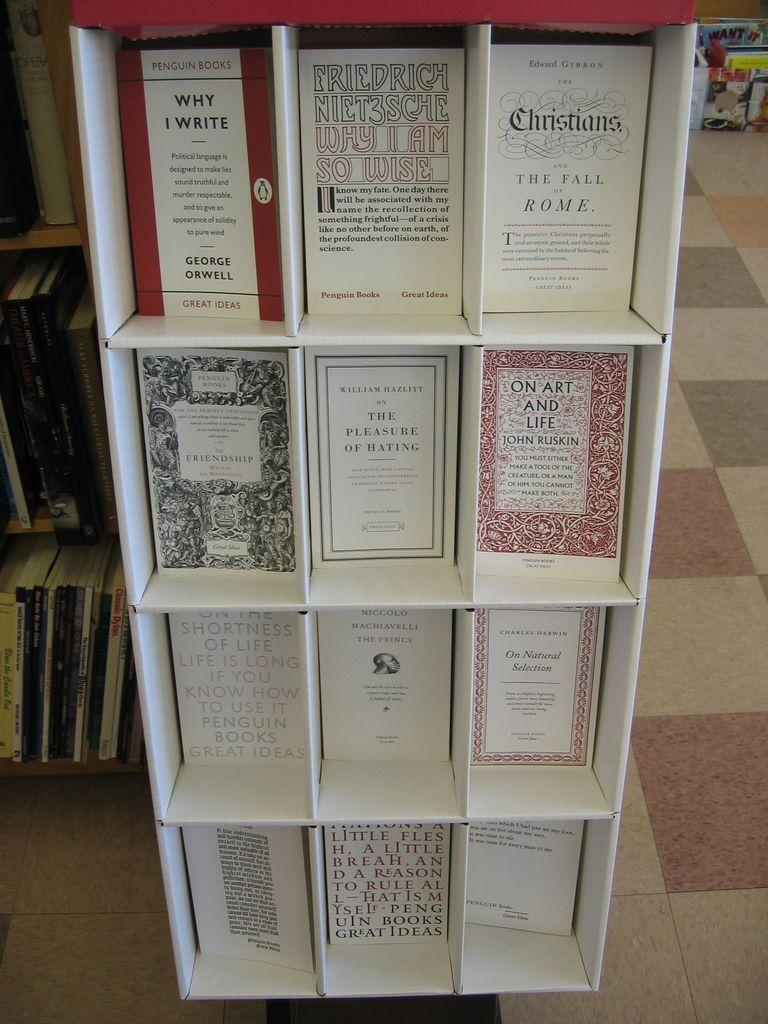<image>
Summarize the visual content of the image. Inspirational Books on the shelf of a library that talk about Christians and Religion with life. 